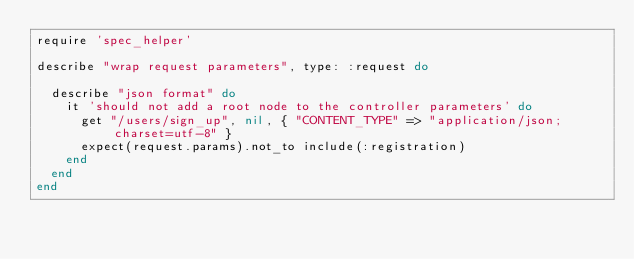Convert code to text. <code><loc_0><loc_0><loc_500><loc_500><_Ruby_>require 'spec_helper'

describe "wrap request parameters", type: :request do

  describe "json format" do
    it 'should not add a root node to the controller parameters' do
      get "/users/sign_up", nil, { "CONTENT_TYPE" => "application/json; charset=utf-8" }
      expect(request.params).not_to include(:registration)
    end
  end
end
</code> 